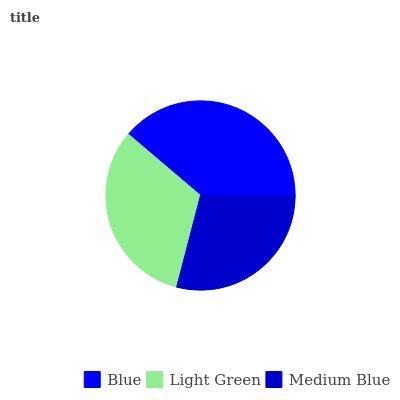Is Medium Blue the minimum?
Answer yes or no. Yes. Is Blue the maximum?
Answer yes or no. Yes. Is Light Green the minimum?
Answer yes or no. No. Is Light Green the maximum?
Answer yes or no. No. Is Blue greater than Light Green?
Answer yes or no. Yes. Is Light Green less than Blue?
Answer yes or no. Yes. Is Light Green greater than Blue?
Answer yes or no. No. Is Blue less than Light Green?
Answer yes or no. No. Is Light Green the high median?
Answer yes or no. Yes. Is Light Green the low median?
Answer yes or no. Yes. Is Medium Blue the high median?
Answer yes or no. No. Is Blue the low median?
Answer yes or no. No. 